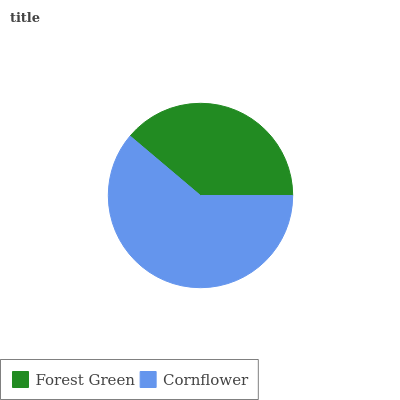Is Forest Green the minimum?
Answer yes or no. Yes. Is Cornflower the maximum?
Answer yes or no. Yes. Is Cornflower the minimum?
Answer yes or no. No. Is Cornflower greater than Forest Green?
Answer yes or no. Yes. Is Forest Green less than Cornflower?
Answer yes or no. Yes. Is Forest Green greater than Cornflower?
Answer yes or no. No. Is Cornflower less than Forest Green?
Answer yes or no. No. Is Cornflower the high median?
Answer yes or no. Yes. Is Forest Green the low median?
Answer yes or no. Yes. Is Forest Green the high median?
Answer yes or no. No. Is Cornflower the low median?
Answer yes or no. No. 